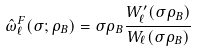Convert formula to latex. <formula><loc_0><loc_0><loc_500><loc_500>\hat { \omega } ^ { F } _ { \ell } ( \sigma ; \rho _ { B } ) = \sigma \rho _ { B } \frac { W _ { \ell } ^ { \prime } ( \sigma \rho _ { B } ) } { W _ { \ell } ( \sigma \rho _ { B } ) }</formula> 